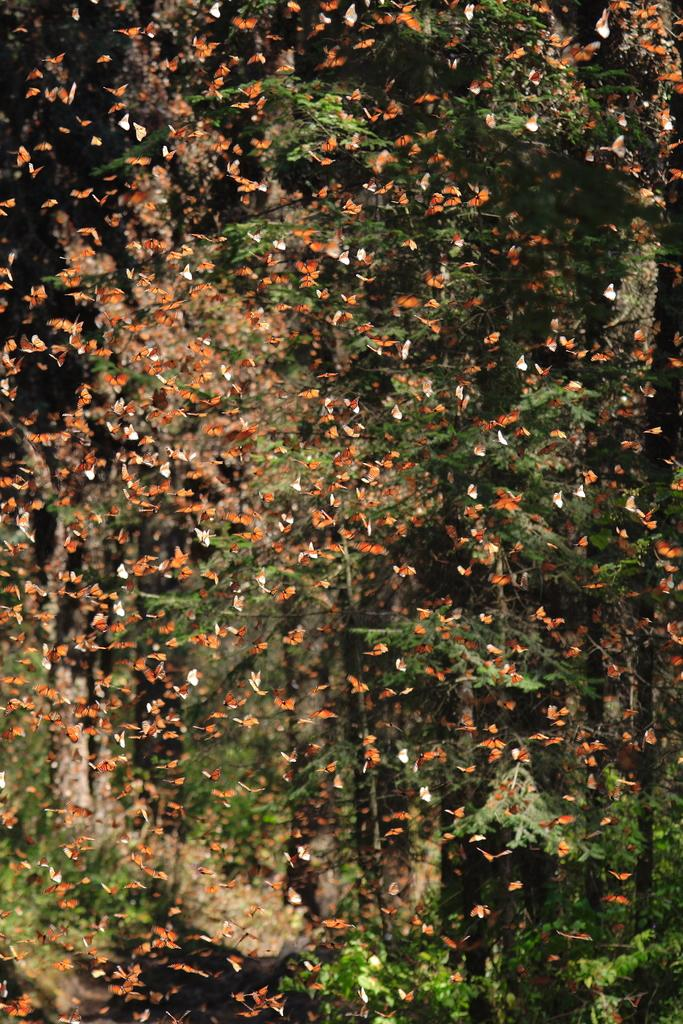What type of animals can be seen flying in the image? There are butterflies flying in the image. What can be seen in the background of the image? There are trees visible in the background of the image. Can you see any wounds on the butterflies in the image? There is no indication of any wounds on the butterflies in the image. Is there a veil visible in the image? There is no veil present in the image. 